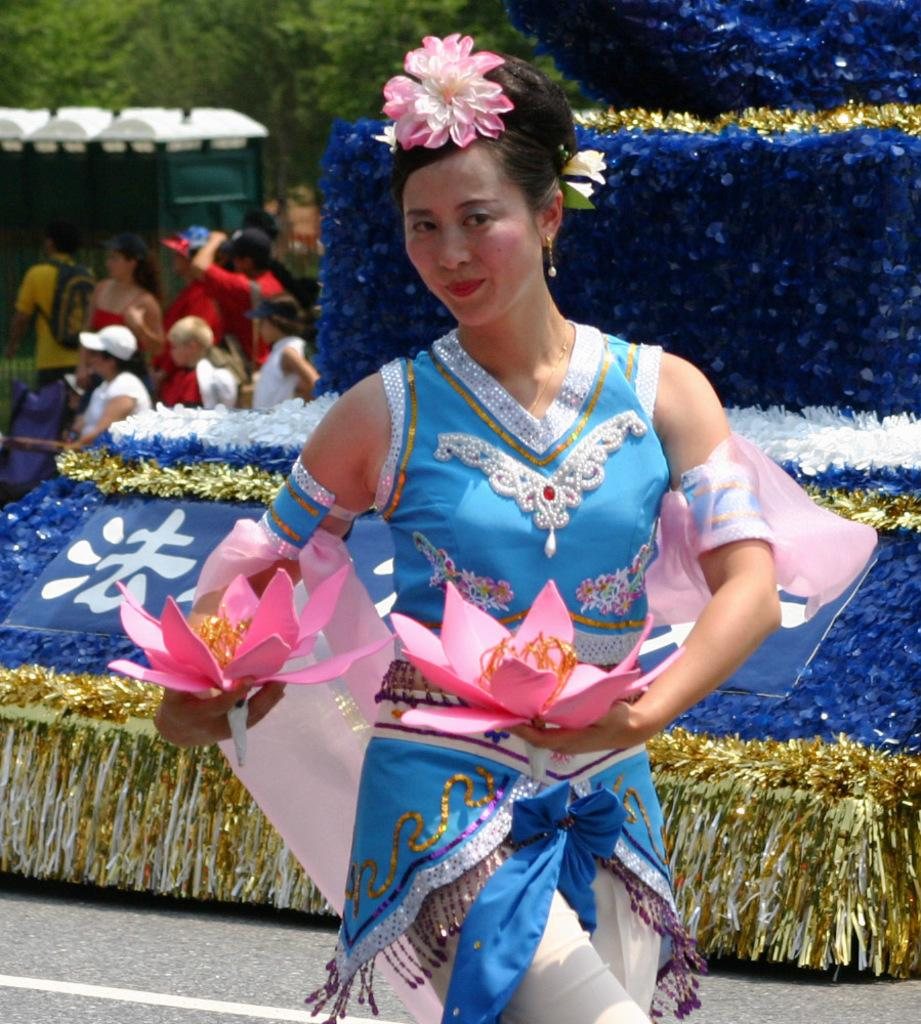Who is the main subject in the image? There is a woman in the image. What is the woman wearing? The woman is wearing a blue dress. What is the woman holding in the image? The woman is holding flowers. What can be seen in the background of the image? There are blue color clothes and trees in the background of the image. How many people are visible in the background? There are many people in the background of the image. What is the taste of the flowers the woman is holding? The taste of the flowers cannot be determined from the image, as taste is not a visual characteristic. 